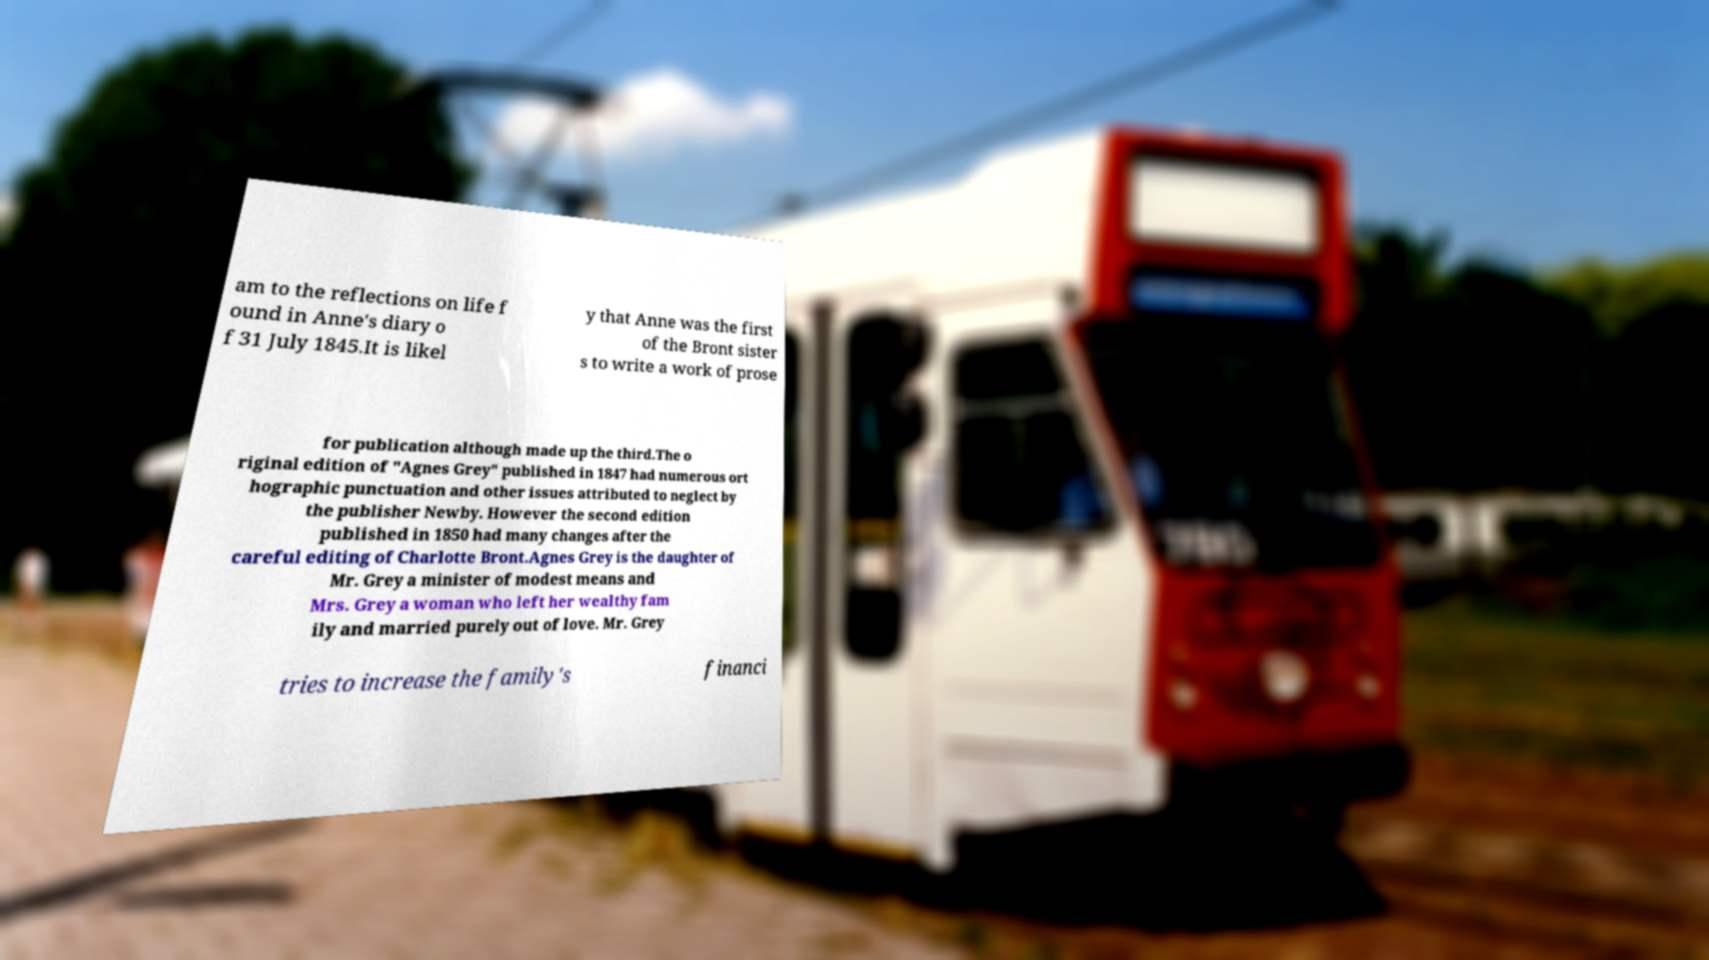Can you read and provide the text displayed in the image?This photo seems to have some interesting text. Can you extract and type it out for me? am to the reflections on life f ound in Anne's diary o f 31 July 1845.It is likel y that Anne was the first of the Bront sister s to write a work of prose for publication although made up the third.The o riginal edition of "Agnes Grey" published in 1847 had numerous ort hographic punctuation and other issues attributed to neglect by the publisher Newby. However the second edition published in 1850 had many changes after the careful editing of Charlotte Bront.Agnes Grey is the daughter of Mr. Grey a minister of modest means and Mrs. Grey a woman who left her wealthy fam ily and married purely out of love. Mr. Grey tries to increase the family's financi 